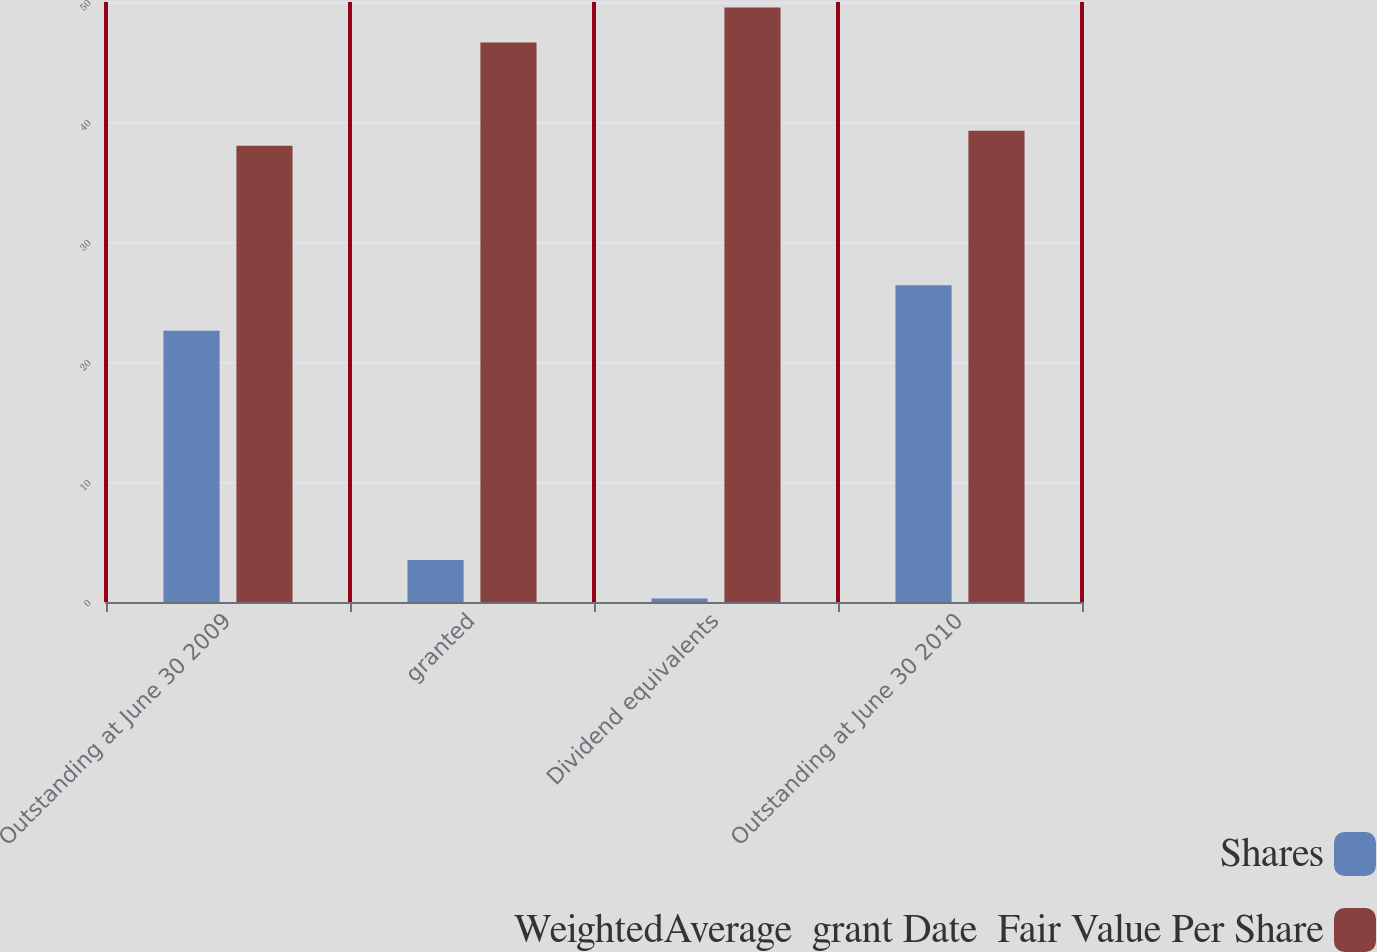Convert chart. <chart><loc_0><loc_0><loc_500><loc_500><stacked_bar_chart><ecel><fcel>Outstanding at June 30 2009<fcel>granted<fcel>Dividend equivalents<fcel>Outstanding at June 30 2010<nl><fcel>Shares<fcel>22.6<fcel>3.5<fcel>0.3<fcel>26.4<nl><fcel>WeightedAverage  grant Date  Fair Value Per Share<fcel>38.02<fcel>46.63<fcel>49.54<fcel>39.27<nl></chart> 